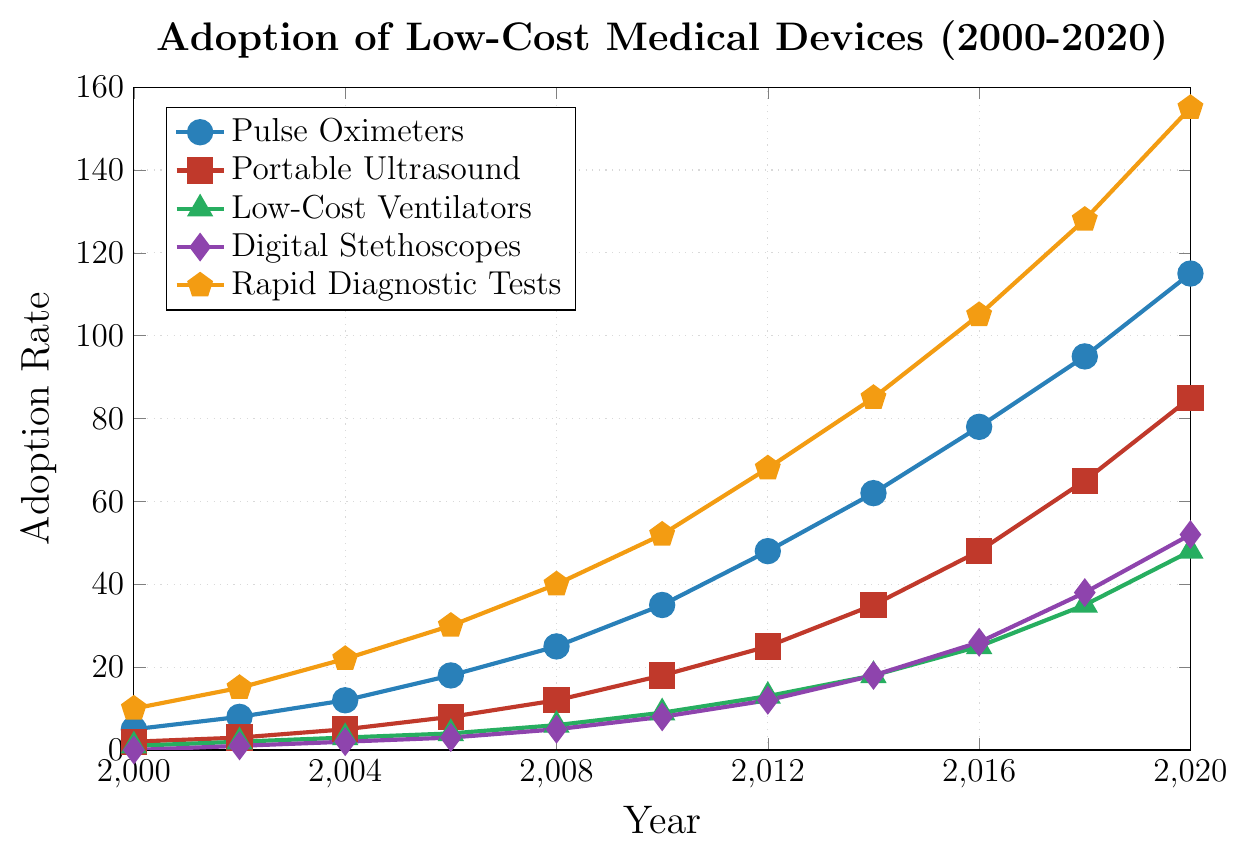What is the overall trend in the adoption rate of Pulse Oximeters from 2000 to 2020? The trend of Pulse Oximeters adoption rate shows a consistent increase over the period from 2000 to 2020, starting at 5 in 2000 and reaching 115 in 2020.
Answer: Increasing Which medical device had the highest adoption rate in 2020? According to the figure, Rapid Diagnostic Tests had the highest adoption rate in 2020, with a value of 155.
Answer: Rapid Diagnostic Tests By how much did the adoption rate of Portable Ultrasound devices increase from 2010 to 2018? The adoption rate of Portable Ultrasound increased from 18 in 2010 to 65 in 2018. The increase is 65 - 18 = 47.
Answer: 47 What was the adoption rate difference between Digital Stethoscopes and Low-Cost Ventilators in the year 2014? In 2014, the adoption rate for Digital Stethoscopes was 18 and for Low-Cost Ventilators was 18. The difference is 18 - 18 = 0.
Answer: 0 Which medical device had the lowest adoption rate in 2008, and what was that rate? In 2008, Low-Cost Ventilators had the lowest adoption rate, which was 6.
Answer: Low-Cost Ventilators, 6 What is the average adoption rate of Rapid Diagnostic Tests across all recorded years? The adoption rates of Rapid Diagnostic Tests recorded are 10, 15, 22, 30, 40, 52, 68, 85, 105, 128, and 155. Their sum is 710 and the number of years is 11. The average adoption rate is 710 / 11 ≈ 64.55.
Answer: 64.55 By what percentage did the adoption rate of Pulse Oximeters increase between 2000 and 2020? The adoption rate of Pulse Oximeters increased from 5 in 2000 to 115 in 2020. The percentage increase is ((115 - 5) / 5) * 100 = 2200%.
Answer: 2200% What were the adoption rates of Digital Stethoscopes and Low-Cost Ventilators in 2012, and which was higher? In 2012, the adoption rate for Digital Stethoscopes was 12, and for Low-Cost Ventilators, it was 13. The adoption rate of Low-Cost Ventilators was higher.
Answer: Low-Cost Ventilators, 13 Which device showed the most significant increase in adoption rate between 2016 and 2020? From the figure, the adoption rates in 2016 and 2020 were compared: Pulse Oximeters (78 to 115), Portable Ultrasound (48 to 85), Low-Cost Ventilators (25 to 48), Digital Stethoscopes (26 to 52), Rapid Diagnostic Tests (105 to 155). The most significant increase is for Rapid Diagnostic Tests (155 - 105 = 50).
Answer: Rapid Diagnostic Tests How does the adoption rate of Portable Ultrasound in 2006 compare to Pulse Oximeters in 2004? The adoption rate of Portable Ultrasound in 2006 (8) is less than that of Pulse Oximeters in 2004 (12).
Answer: Less 